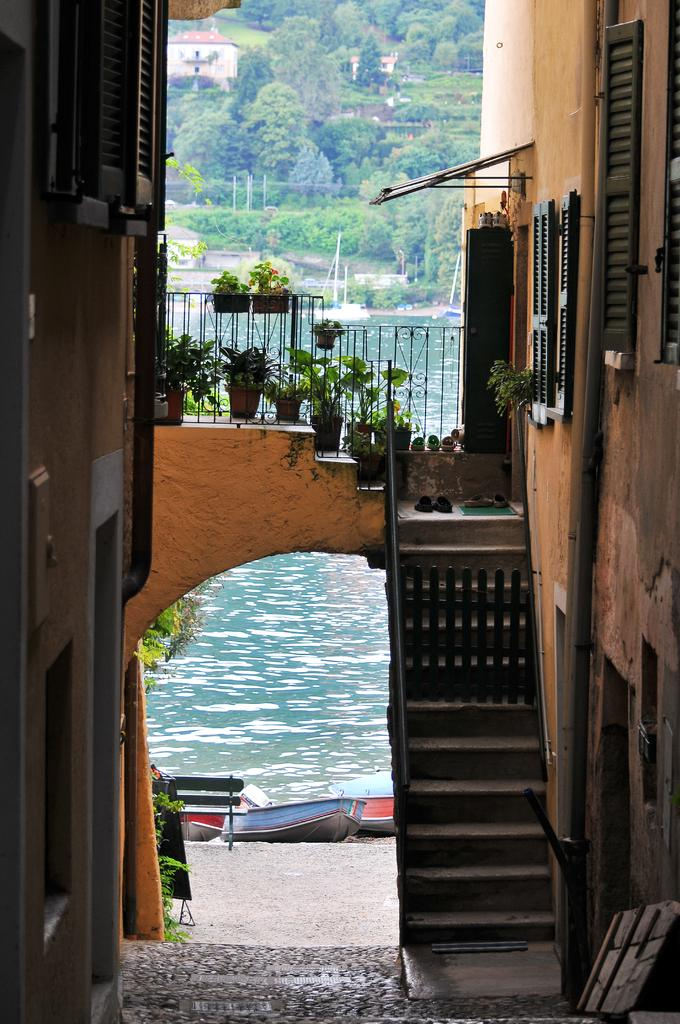What type of natural environment can be seen in the background of the image? There are trees and water visible in the background of the image. What architectural feature is present in the image? There is a staircase in the image. What type of vegetation is present in the image? There are plants with pots in the image. What type of transportation can be seen in the image? There are boats in the image. What type of man-made structures are visible in the image? There are buildings in the image. What type of grape is being used as a decoration on the arm of the front building in the image? There is no grape present in the image, nor is there any indication of decoration on the buildings. 